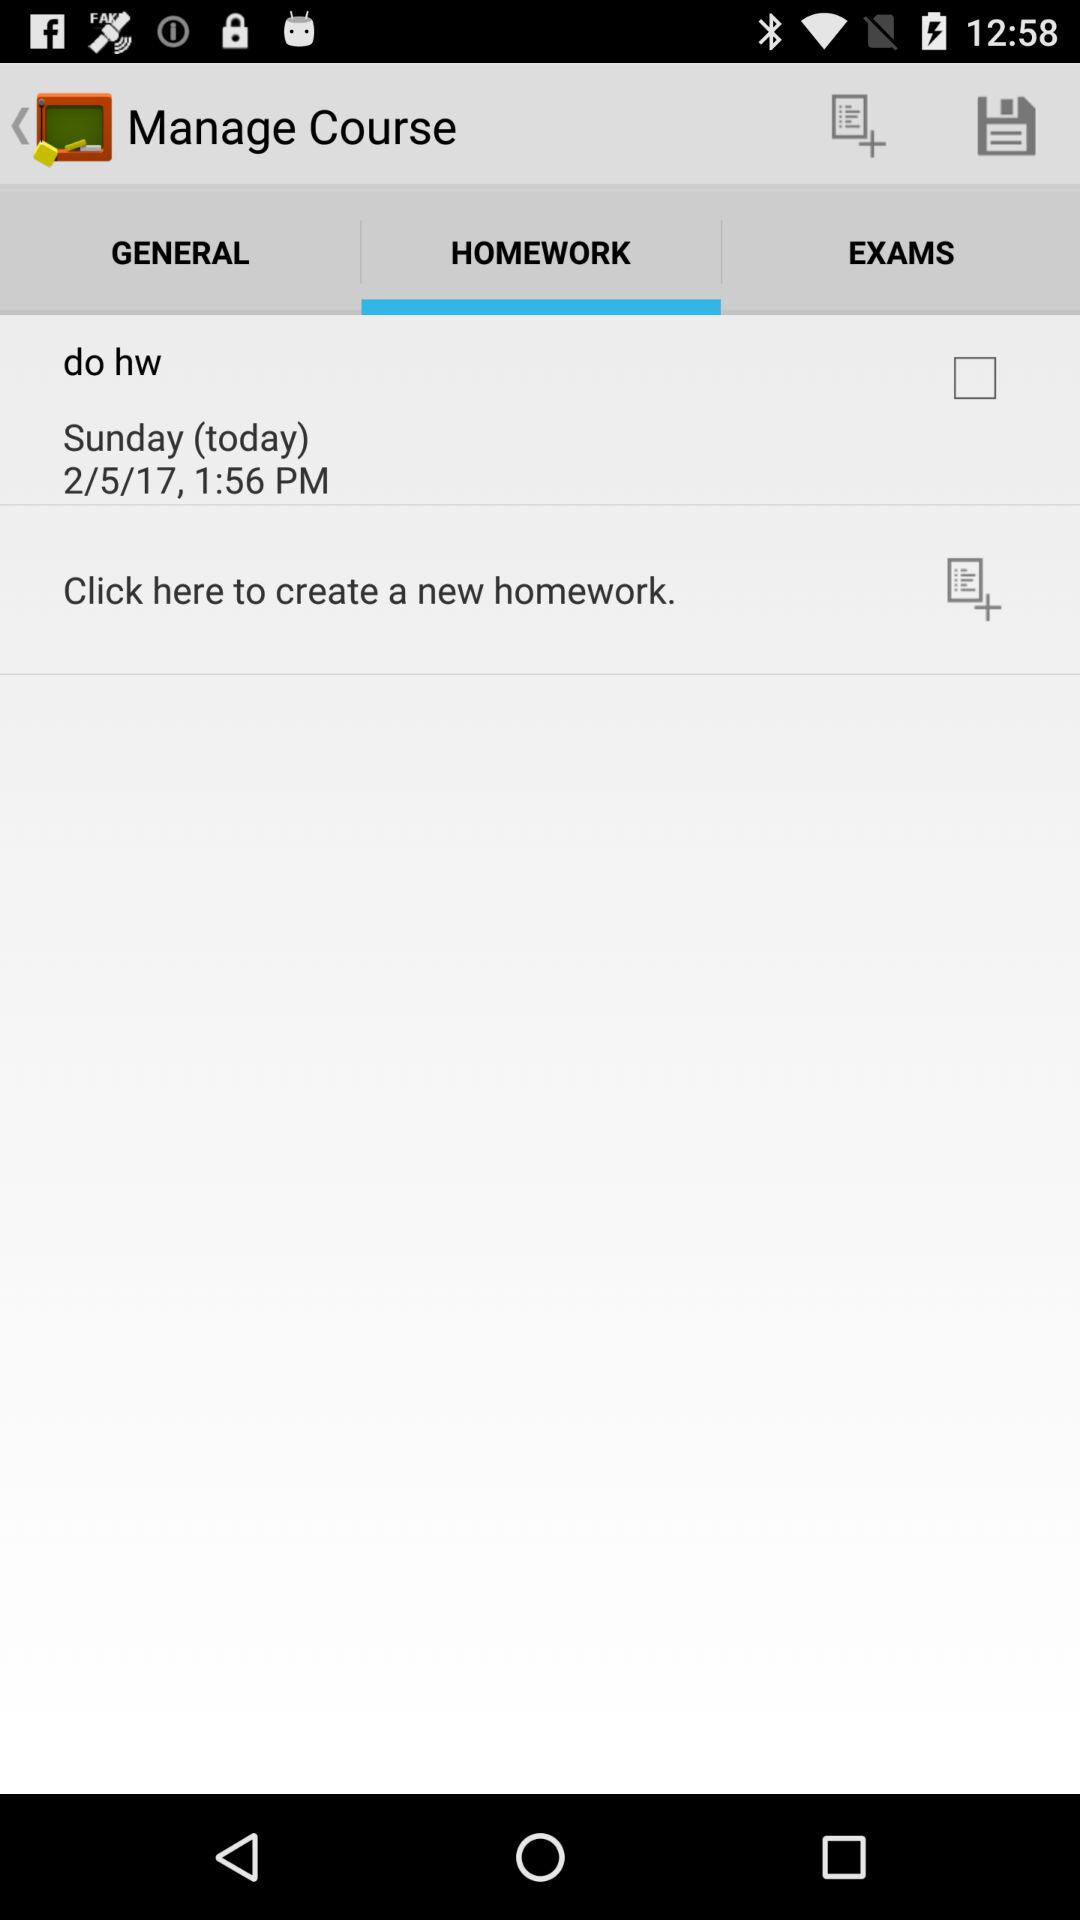Which tab is selected? The selected tab is "HOMEWORK". 